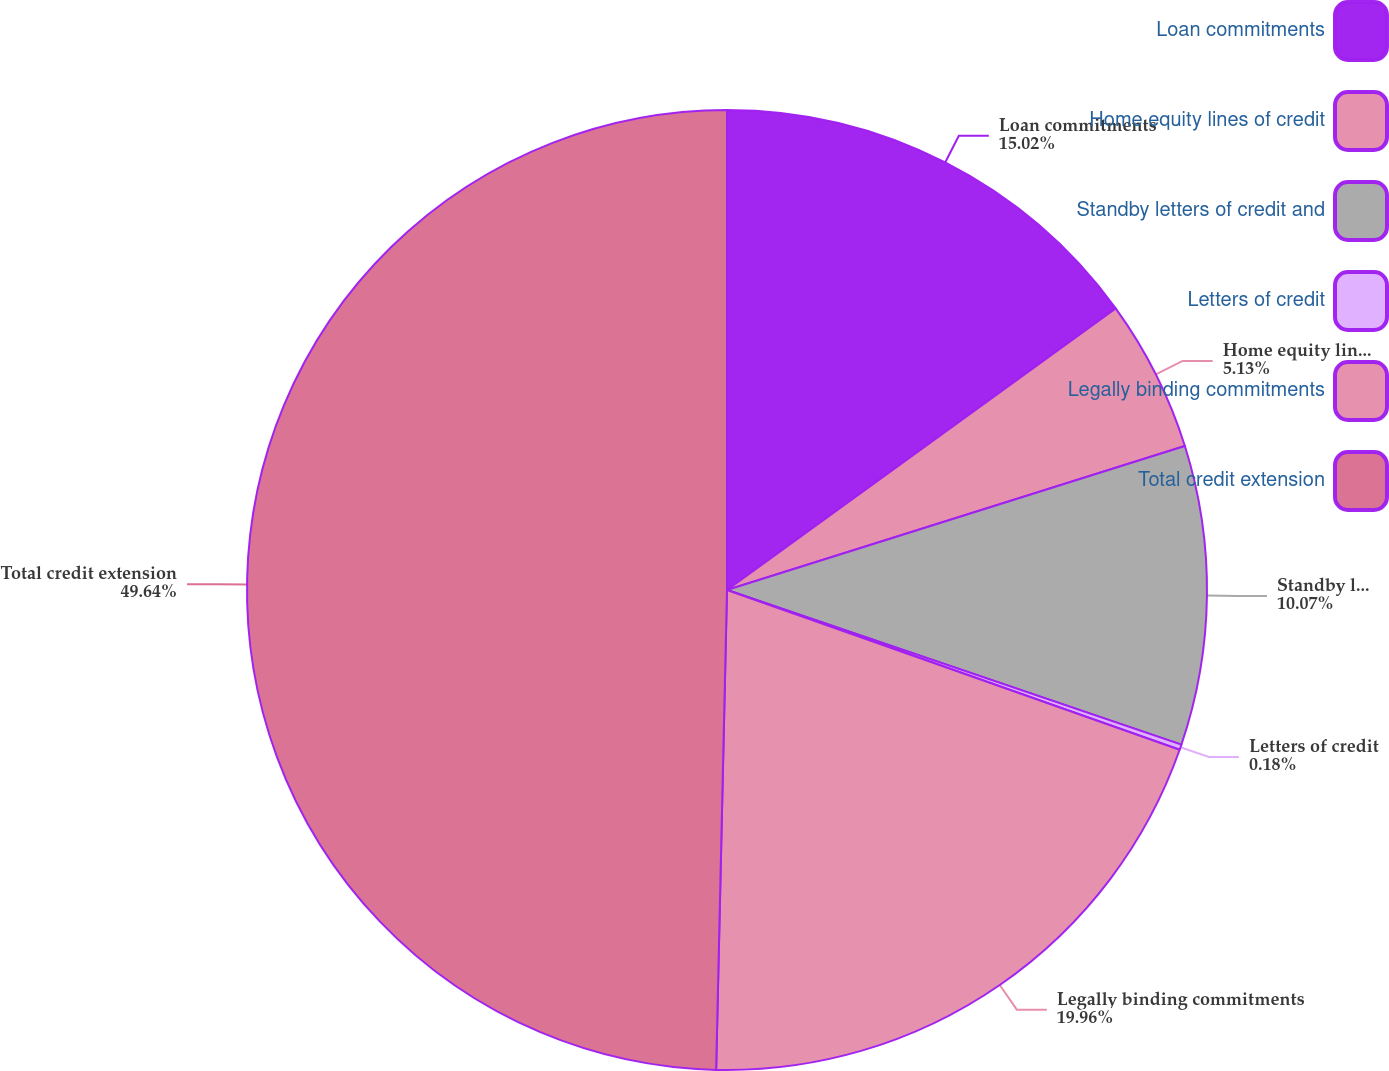Convert chart. <chart><loc_0><loc_0><loc_500><loc_500><pie_chart><fcel>Loan commitments<fcel>Home equity lines of credit<fcel>Standby letters of credit and<fcel>Letters of credit<fcel>Legally binding commitments<fcel>Total credit extension<nl><fcel>15.02%<fcel>5.13%<fcel>10.07%<fcel>0.18%<fcel>19.96%<fcel>49.64%<nl></chart> 